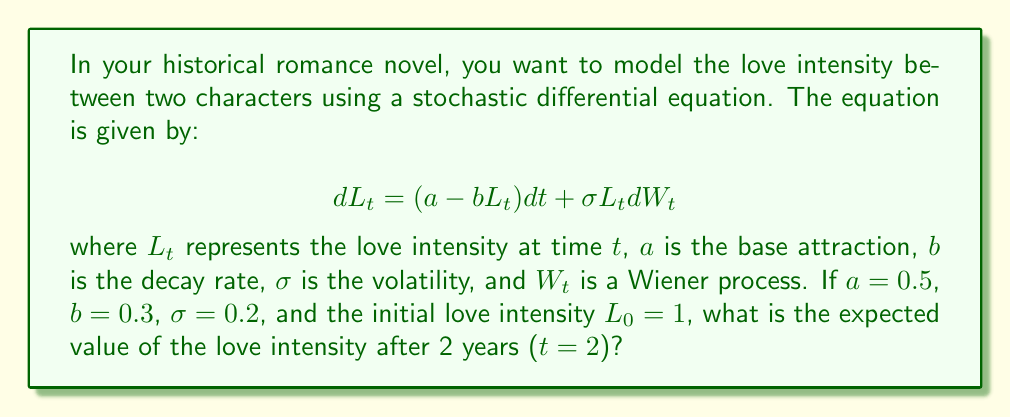Could you help me with this problem? To solve this problem, we need to follow these steps:

1) The stochastic differential equation given is an example of a geometric Ornstein-Uhlenbeck process. For this type of process, we can derive the expected value using the following formula:

   $$E[L_t] = L_0e^{-bt} + \frac{a}{b}(1 - e^{-bt})$$

2) We are given the following parameters:
   $a = 0.5$ (base attraction)
   $b = 0.3$ (decay rate)
   $L_0 = 1$ (initial love intensity)
   $t = 2$ (time in years)

3) Let's substitute these values into our formula:

   $$E[L_2] = 1 \cdot e^{-0.3 \cdot 2} + \frac{0.5}{0.3}(1 - e^{-0.3 \cdot 2})$$

4) Let's calculate $e^{-0.3 \cdot 2}$ first:
   $e^{-0.6} \approx 0.5488$

5) Now we can substitute this value:

   $$E[L_2] = 1 \cdot 0.5488 + \frac{0.5}{0.3}(1 - 0.5488)$$

6) Simplify:
   $$E[L_2] = 0.5488 + 1.6667(0.4512)$$
   $$E[L_2] = 0.5488 + 0.7520$$
   $$E[L_2] = 1.3008$$

Therefore, the expected value of the love intensity after 2 years is approximately 1.3008.
Answer: 1.3008 